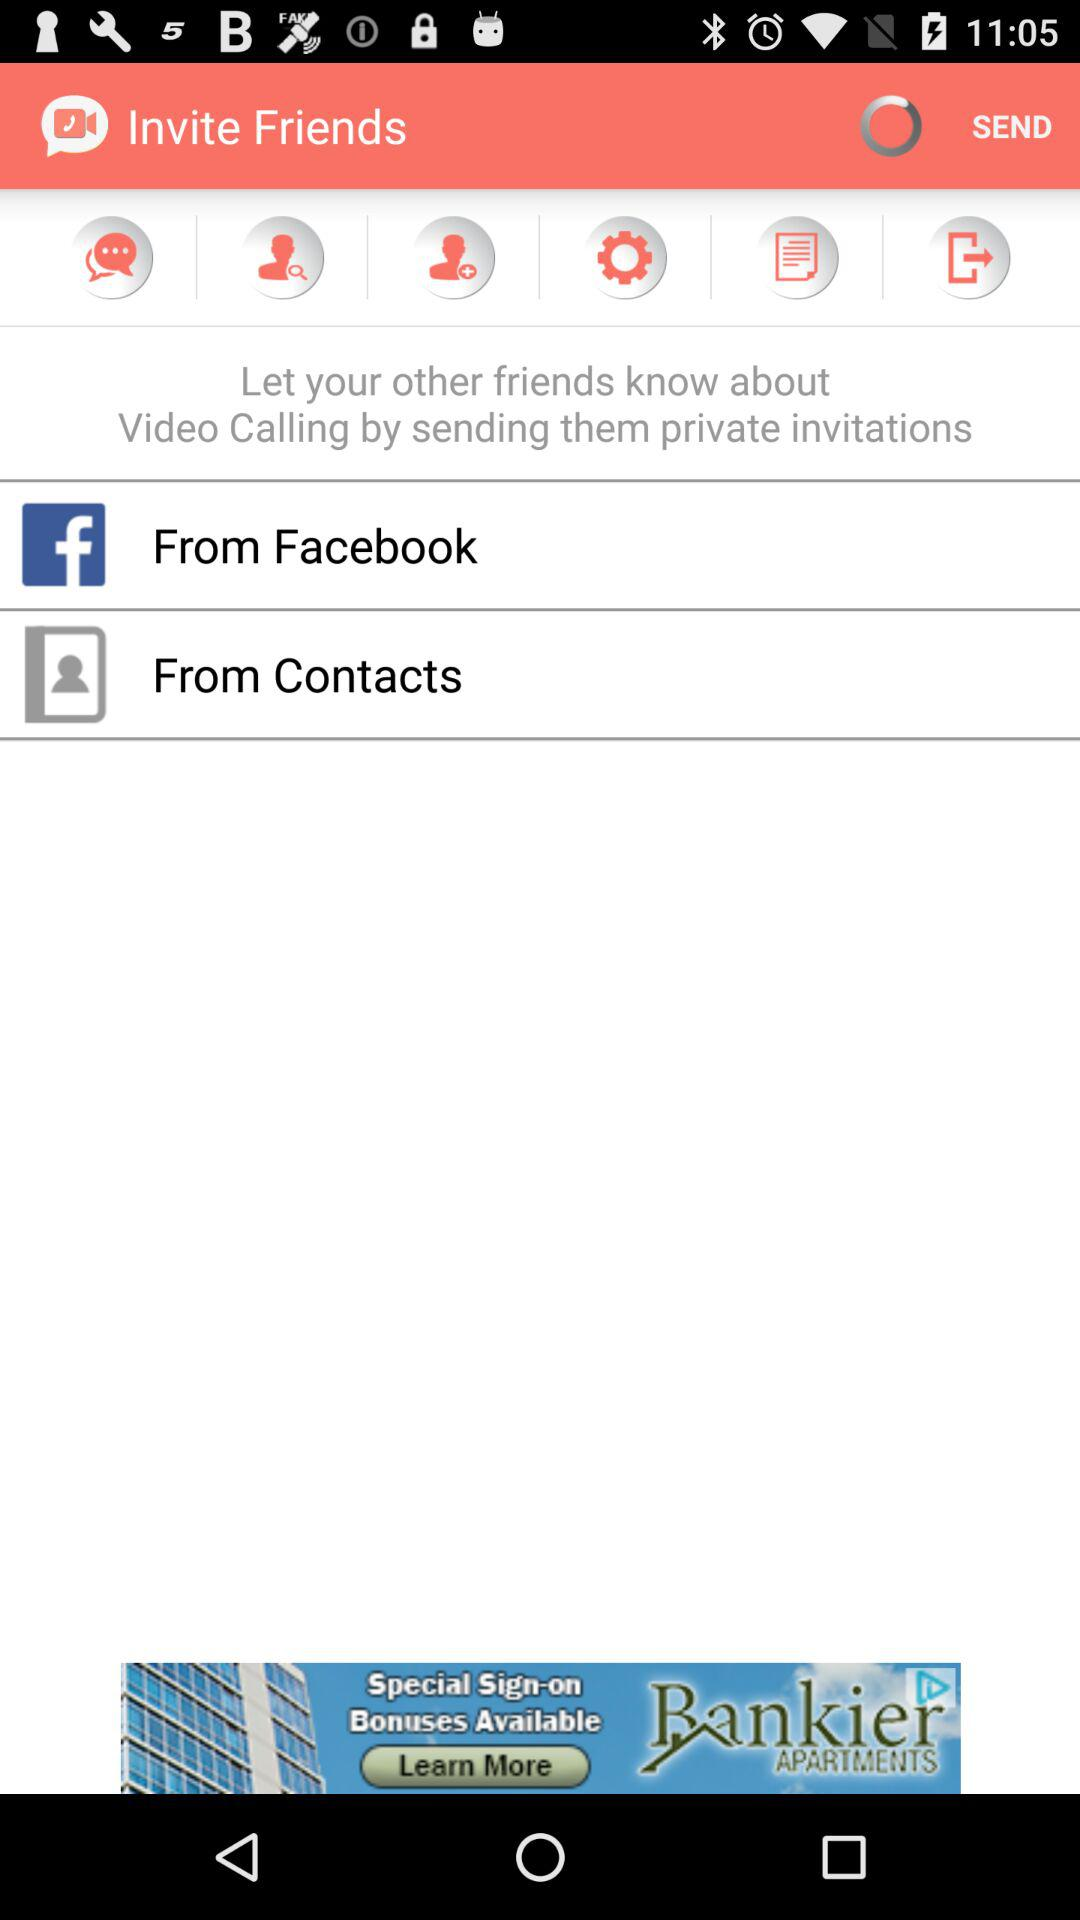What applications can be used to invite? You can use "Facebook" and "Contacts". 